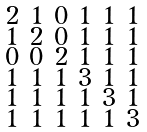Convert formula to latex. <formula><loc_0><loc_0><loc_500><loc_500>\begin{smallmatrix} 2 & 1 & 0 & 1 & 1 & 1 \\ 1 & 2 & 0 & 1 & 1 & 1 \\ 0 & 0 & 2 & 1 & 1 & 1 \\ 1 & 1 & 1 & 3 & 1 & 1 \\ 1 & 1 & 1 & 1 & 3 & 1 \\ 1 & 1 & 1 & 1 & 1 & 3 \end{smallmatrix}</formula> 